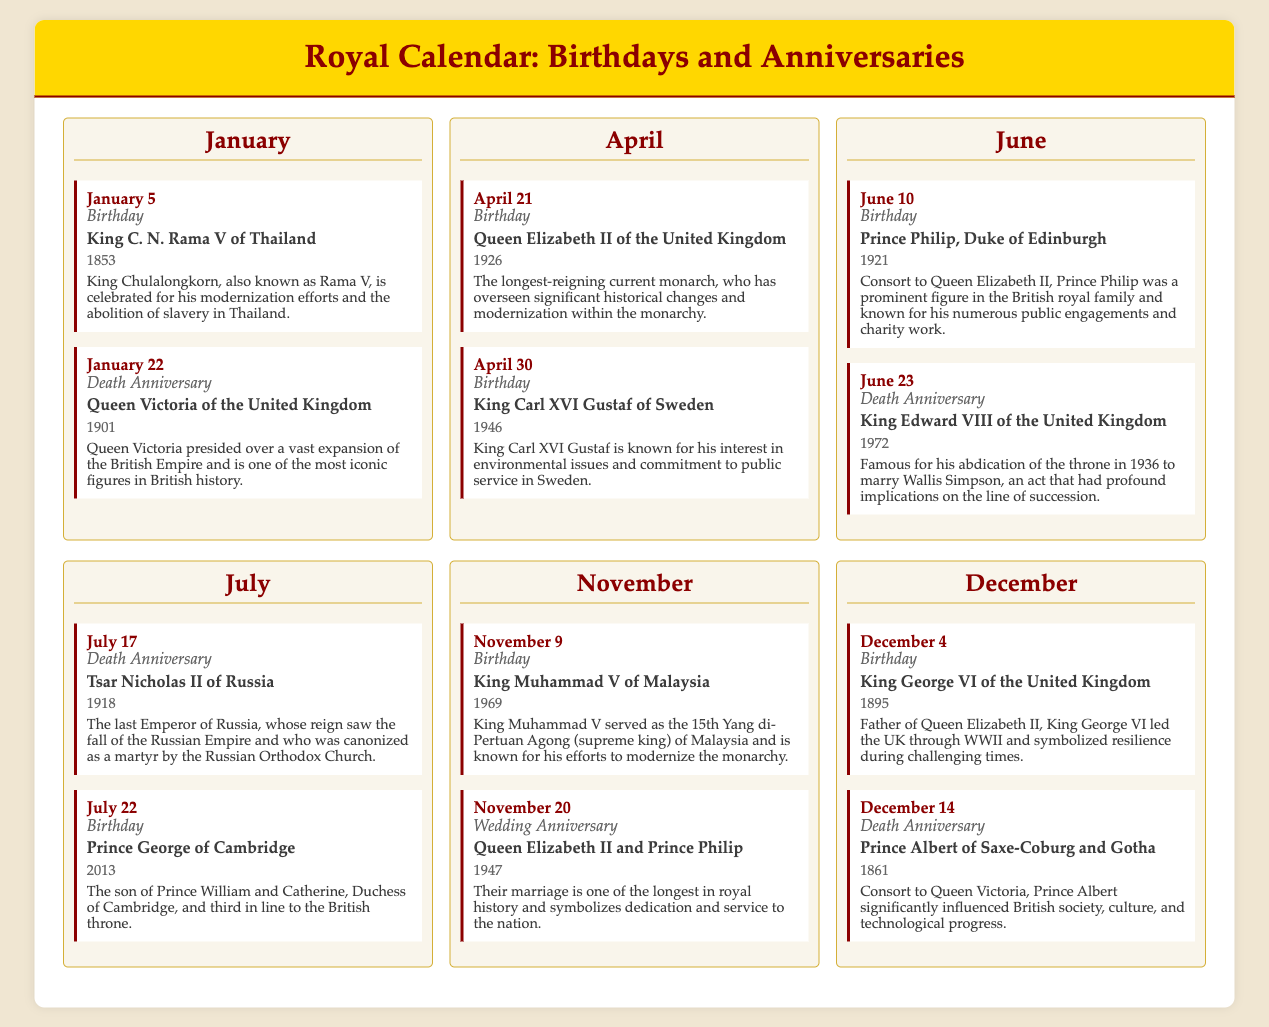What is the birthday of Queen Elizabeth II? Queen Elizabeth II's birthday is listed in the document as April 21, 1926.
Answer: April 21, 1926 Who is commemorated on January 22? The document states that January 22 is the death anniversary of Queen Victoria of the United Kingdom.
Answer: Queen Victoria When did King George VI of the United Kingdom die? The death date of King George VI is not mentioned, but his birthday is listed as December 4, 1895.
Answer: Not mentioned How many events are listed for the month of June? There are two events for June detailed in the document: one birthday and one death anniversary.
Answer: 2 Which monarch is known for modernizing Thailand? The document highlights King C. N. Rama V of Thailand as a monarch known for his modernization efforts.
Answer: King C. N. Rama V What year did Tsar Nicholas II of Russia die? Tsar Nicholas II's death year is specified in the document as 1918.
Answer: 1918 What notable event occurred on November 20? The document indicates that November 20 is the wedding anniversary of Queen Elizabeth II and Prince Philip.
Answer: Wedding Anniversary How many birthdays are listed in the month of April? The text outlines a total of two birthdays in April, specifically for Queen Elizabeth II and King Carl XVI Gustaf of Sweden.
Answer: 2 